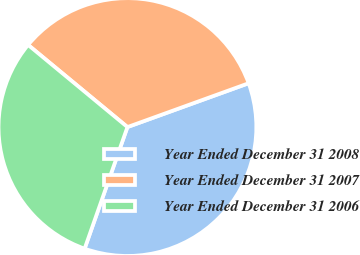Convert chart. <chart><loc_0><loc_0><loc_500><loc_500><pie_chart><fcel>Year Ended December 31 2008<fcel>Year Ended December 31 2007<fcel>Year Ended December 31 2006<nl><fcel>35.91%<fcel>33.48%<fcel>30.61%<nl></chart> 